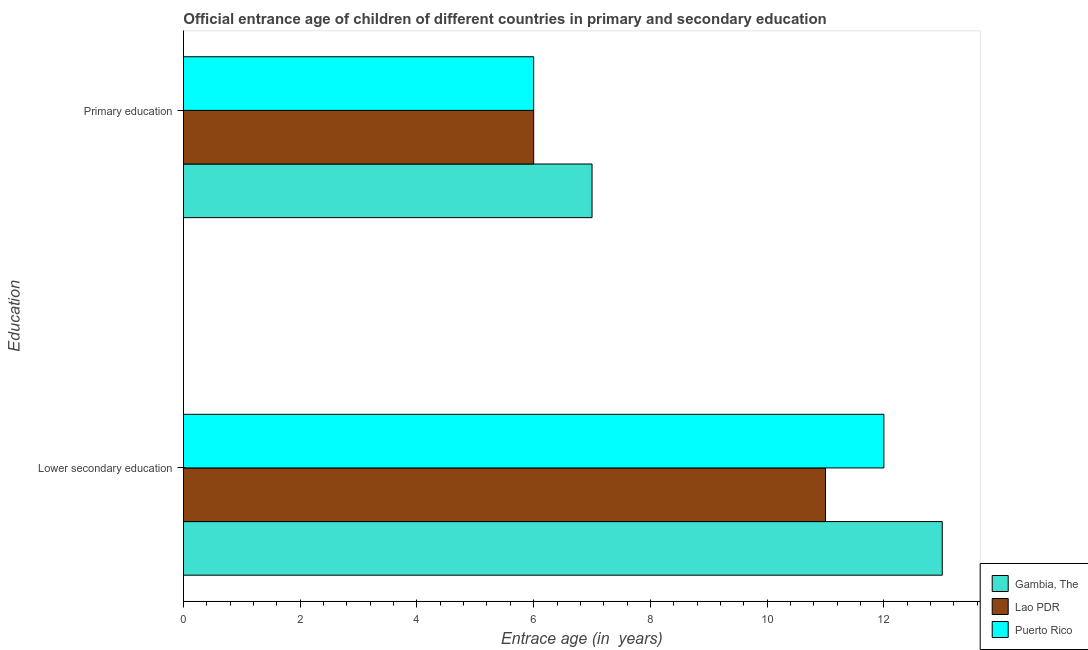How many different coloured bars are there?
Give a very brief answer. 3. How many groups of bars are there?
Ensure brevity in your answer.  2. Are the number of bars per tick equal to the number of legend labels?
Your response must be concise. Yes. Are the number of bars on each tick of the Y-axis equal?
Provide a short and direct response. Yes. What is the entrance age of children in lower secondary education in Lao PDR?
Your answer should be very brief. 11. Across all countries, what is the maximum entrance age of chiildren in primary education?
Your response must be concise. 7. Across all countries, what is the minimum entrance age of children in lower secondary education?
Ensure brevity in your answer.  11. In which country was the entrance age of children in lower secondary education maximum?
Keep it short and to the point. Gambia, The. In which country was the entrance age of children in lower secondary education minimum?
Your answer should be very brief. Lao PDR. What is the total entrance age of chiildren in primary education in the graph?
Give a very brief answer. 19. What is the difference between the entrance age of children in lower secondary education in Gambia, The and the entrance age of chiildren in primary education in Puerto Rico?
Ensure brevity in your answer.  7. In how many countries, is the entrance age of children in lower secondary education greater than 8 years?
Make the answer very short. 3. What is the ratio of the entrance age of children in lower secondary education in Lao PDR to that in Puerto Rico?
Provide a short and direct response. 0.92. Is the entrance age of children in lower secondary education in Gambia, The less than that in Lao PDR?
Ensure brevity in your answer.  No. In how many countries, is the entrance age of chiildren in primary education greater than the average entrance age of chiildren in primary education taken over all countries?
Offer a very short reply. 1. What does the 3rd bar from the top in Primary education represents?
Ensure brevity in your answer.  Gambia, The. What does the 1st bar from the bottom in Lower secondary education represents?
Your answer should be compact. Gambia, The. How many countries are there in the graph?
Your answer should be compact. 3. What is the difference between two consecutive major ticks on the X-axis?
Your response must be concise. 2. Are the values on the major ticks of X-axis written in scientific E-notation?
Make the answer very short. No. Does the graph contain any zero values?
Provide a short and direct response. No. Does the graph contain grids?
Your answer should be very brief. No. How are the legend labels stacked?
Provide a succinct answer. Vertical. What is the title of the graph?
Offer a terse response. Official entrance age of children of different countries in primary and secondary education. Does "United States" appear as one of the legend labels in the graph?
Your answer should be compact. No. What is the label or title of the X-axis?
Provide a short and direct response. Entrace age (in  years). What is the label or title of the Y-axis?
Provide a succinct answer. Education. What is the Entrace age (in  years) of Lao PDR in Lower secondary education?
Give a very brief answer. 11. What is the Entrace age (in  years) of Puerto Rico in Lower secondary education?
Give a very brief answer. 12. What is the Entrace age (in  years) in Lao PDR in Primary education?
Offer a very short reply. 6. What is the Entrace age (in  years) of Puerto Rico in Primary education?
Your response must be concise. 6. Across all Education, what is the maximum Entrace age (in  years) in Gambia, The?
Your answer should be very brief. 13. Across all Education, what is the maximum Entrace age (in  years) of Puerto Rico?
Keep it short and to the point. 12. Across all Education, what is the minimum Entrace age (in  years) in Gambia, The?
Offer a terse response. 7. Across all Education, what is the minimum Entrace age (in  years) in Lao PDR?
Make the answer very short. 6. Across all Education, what is the minimum Entrace age (in  years) of Puerto Rico?
Your answer should be very brief. 6. What is the total Entrace age (in  years) in Lao PDR in the graph?
Give a very brief answer. 17. What is the difference between the Entrace age (in  years) in Gambia, The in Lower secondary education and that in Primary education?
Offer a terse response. 6. What is the difference between the Entrace age (in  years) of Lao PDR in Lower secondary education and that in Primary education?
Keep it short and to the point. 5. What is the average Entrace age (in  years) in Lao PDR per Education?
Keep it short and to the point. 8.5. What is the average Entrace age (in  years) of Puerto Rico per Education?
Provide a short and direct response. 9. What is the difference between the Entrace age (in  years) in Gambia, The and Entrace age (in  years) in Lao PDR in Lower secondary education?
Offer a very short reply. 2. What is the difference between the Entrace age (in  years) in Gambia, The and Entrace age (in  years) in Puerto Rico in Lower secondary education?
Offer a terse response. 1. What is the difference between the Entrace age (in  years) in Lao PDR and Entrace age (in  years) in Puerto Rico in Lower secondary education?
Your answer should be compact. -1. What is the difference between the Entrace age (in  years) of Gambia, The and Entrace age (in  years) of Puerto Rico in Primary education?
Make the answer very short. 1. What is the ratio of the Entrace age (in  years) in Gambia, The in Lower secondary education to that in Primary education?
Provide a succinct answer. 1.86. What is the ratio of the Entrace age (in  years) in Lao PDR in Lower secondary education to that in Primary education?
Offer a terse response. 1.83. What is the ratio of the Entrace age (in  years) of Puerto Rico in Lower secondary education to that in Primary education?
Provide a short and direct response. 2. What is the difference between the highest and the second highest Entrace age (in  years) of Gambia, The?
Keep it short and to the point. 6. What is the difference between the highest and the lowest Entrace age (in  years) in Gambia, The?
Your response must be concise. 6. What is the difference between the highest and the lowest Entrace age (in  years) in Lao PDR?
Give a very brief answer. 5. What is the difference between the highest and the lowest Entrace age (in  years) of Puerto Rico?
Keep it short and to the point. 6. 